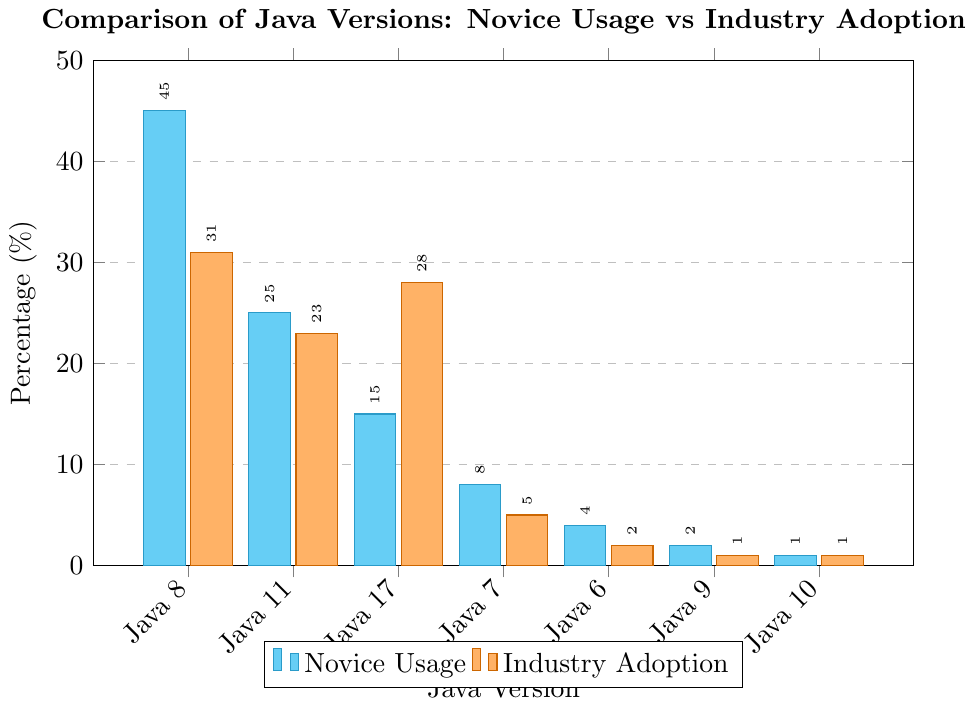Which Java version do novice users prefer the most? The tallest cyan bar on the graph represents the Java version most preferred by novice users. This bar is for Java 8.
Answer: Java 8 Which Java version has the highest industry adoption rate? The tallest orange bar indicates the Java version with the highest industry adoption rate. This is for Java 8.
Answer: Java 8 How much higher is the novice usage percentage of Java 8 compared to the industry adoption percentage? The novice usage percentage for Java 8 is 45%, and the industry adoption percentage is 31%. The difference is 45% - 31%.
Answer: 14% What is the total percentage of novice usage of Java 7, Java 6, Java 9, and Java 10 combined? Sum the novice usage percentages: 8% (Java 7) + 4% (Java 6) + 2% (Java 9) + 1% (Java 10) = 15%.
Answer: 15% How does the novice usage of Java 11 compare to its industry adoption rate? The novice usage of Java 11 is represented by a cyan bar with a value of 25%, while the industry adoption rate is shown by an orange bar with a value of 23%.
Answer: Novice usage is 2% higher Which Java versions have the same industry adoption rate? Orange bars of equal height indicate the same industry adoption rate. Java 9 and Java 10 both have an industry adoption rate of 1%.
Answer: Java 9, Java 10 What percentage more do novice programmers use Java 6 compared to Java 9? The novice usage percentage for Java 6 is 4%, and for Java 9, it is 2%. The difference is 4% - 2%.
Answer: 2% more What is the average industry adoption rate for Java 7 and Java 17? Sum the industry adoption rates for Java 7 and Java 17 and divide by 2. (5% + 28%) / 2 = 16.5%.
Answer: 16.5% Which Java version shows the largest discrepancy between novice usage and industry adoption rates, and what is the value? The greatest difference between cyan and orange bars corresponds to Java 8, with novice usage at 45% and industry adoption at 31%. The difference is 45% - 31%.
Answer: Java 8, 14% 